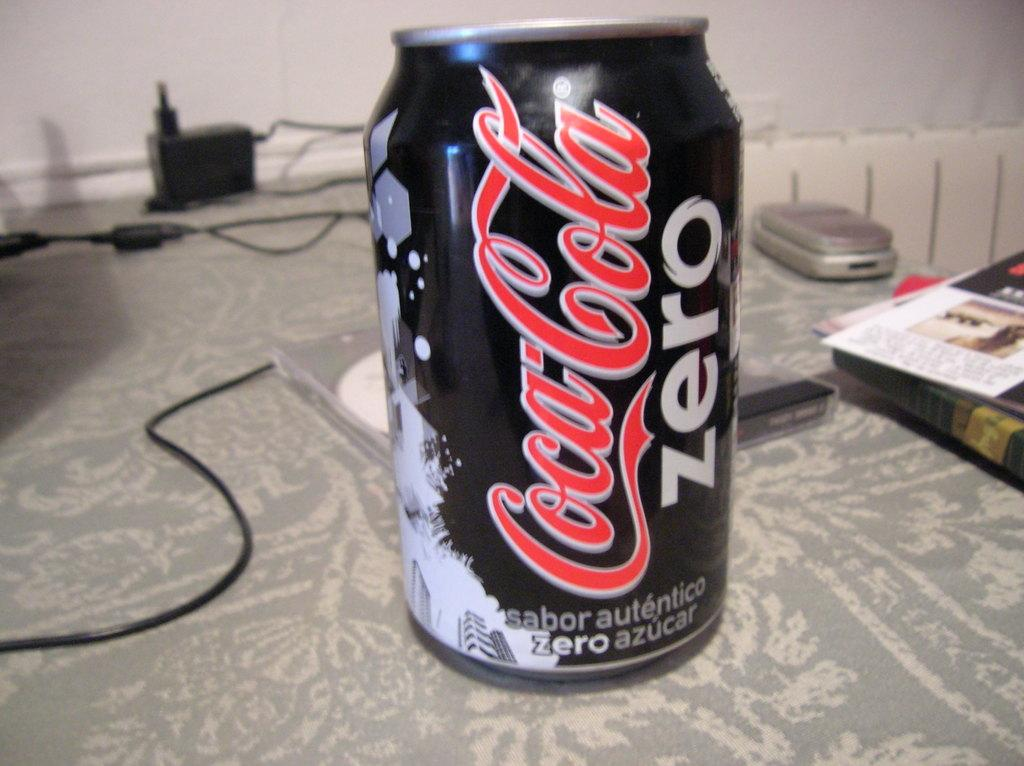<image>
Create a compact narrative representing the image presented. A black and red Coca Cola Zero can. 